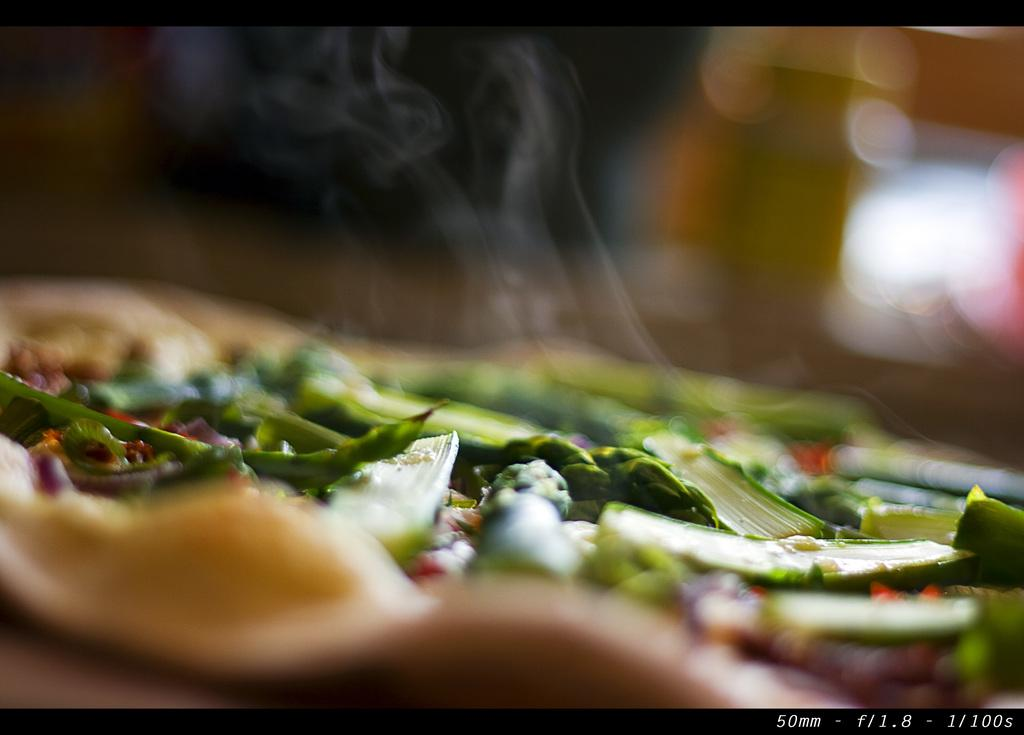What type of food items can be seen in the image? There are vegetables in the image. What else is visible in the image besides the vegetables? There is smoke visible in the image. How would you describe the quality of the image? The image is slightly blurry. Is there any text or logo present in the image? Yes, there is a watermark in the bottom right corner of the image. How many balls are rolling on the ground in the image? There are no balls present in the image. Was the image taken during an earthquake? There is no indication of an earthquake in the image, as it only features vegetables and smoke. 